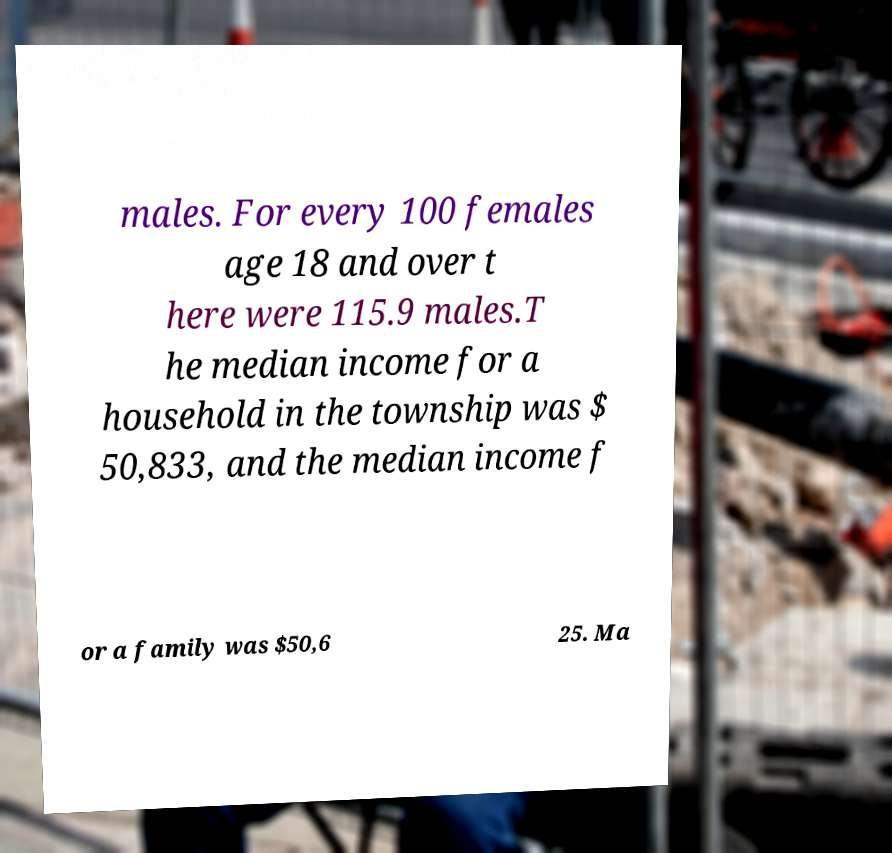Could you assist in decoding the text presented in this image and type it out clearly? males. For every 100 females age 18 and over t here were 115.9 males.T he median income for a household in the township was $ 50,833, and the median income f or a family was $50,6 25. Ma 